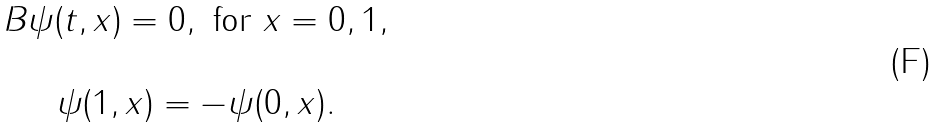Convert formula to latex. <formula><loc_0><loc_0><loc_500><loc_500>\begin{array} { c } B \psi ( t , x ) = 0 , \text { for } x = 0 , 1 , \\ \\ \psi ( 1 , x ) = - \psi ( 0 , x ) . \end{array}</formula> 